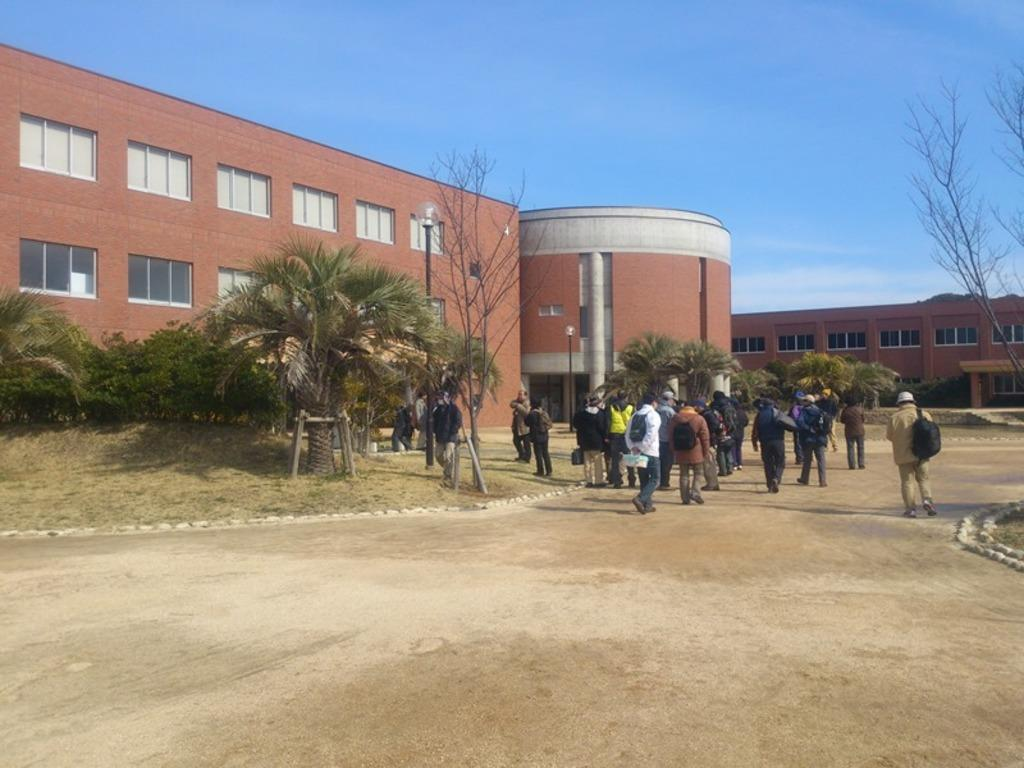What is happening on the right side of the image? There are people walking on the right side of the image. What can be seen on the left side of the image? There are trees on the left side of the image. What is located behind the trees? There is a building behind the trees. How would you describe the weather in the image? The sky is sunny at the top of the image, indicating a clear and sunny day. What type of hose is being used by the people walking on the right side of the image? There is no hose present in the image; the people are simply walking. How much lumber is visible in the image? There is no lumber present in the image. 